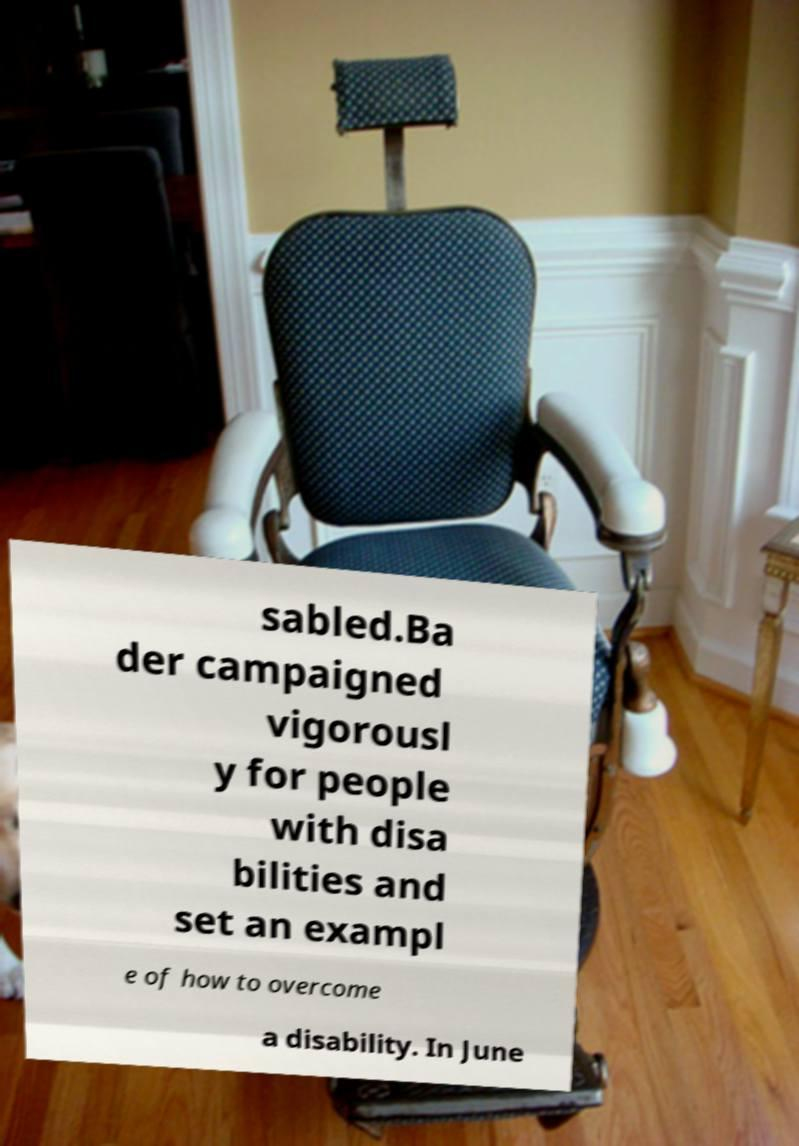Could you extract and type out the text from this image? sabled.Ba der campaigned vigorousl y for people with disa bilities and set an exampl e of how to overcome a disability. In June 